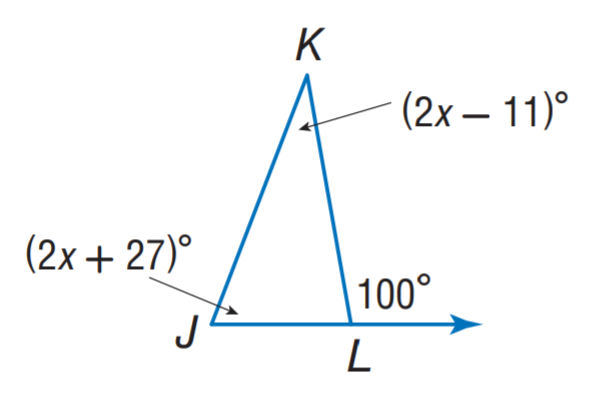Question: Find m \angle J K L.
Choices:
A. 21
B. 31
C. 43
D. 84
Answer with the letter. Answer: B 